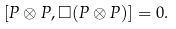<formula> <loc_0><loc_0><loc_500><loc_500>[ P \otimes P , \Box ( P \otimes P ) ] = 0 .</formula> 